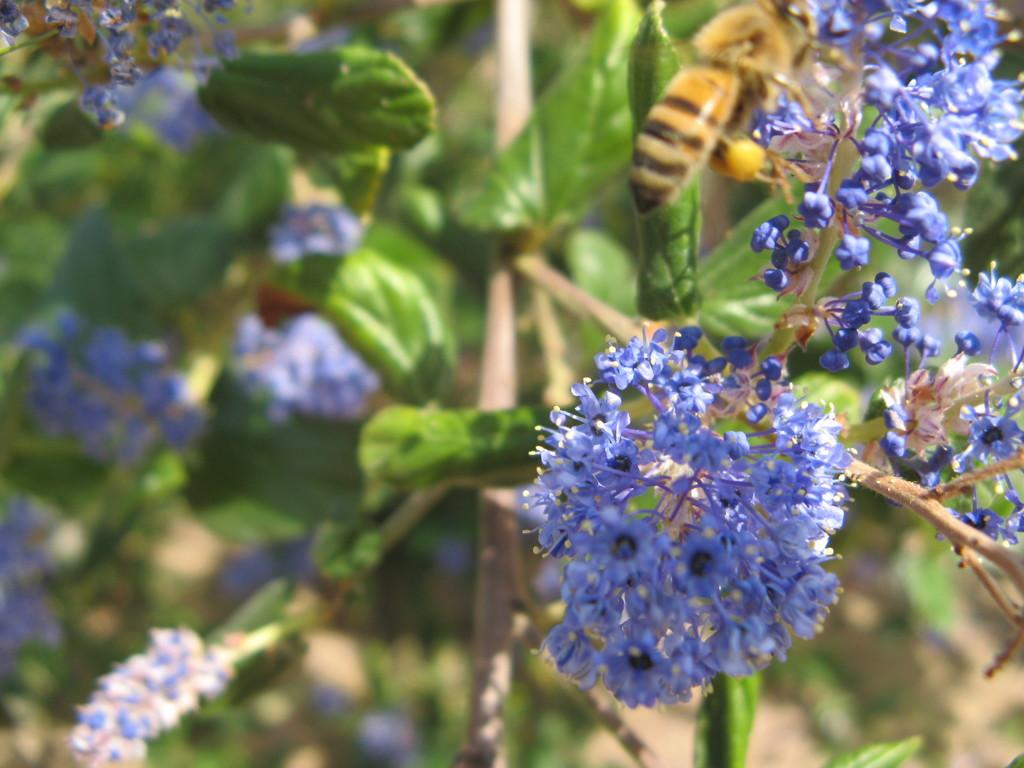What color are the flowers in the image? The flowers in the image are blue. Where are the flowers located? The flowers are on plants. What other living organism can be seen in the image? There is an insect in the image. What colors can be observed on the insect? The insect has brown and black colors. What type of art is displayed on the wall in the image? There is no mention of a wall or any art in the image; it primarily features flowers, plants, and an insect. 